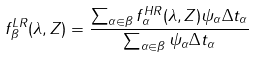Convert formula to latex. <formula><loc_0><loc_0><loc_500><loc_500>f ^ { L R } _ { \beta } ( \lambda , Z ) = \frac { \sum _ { \alpha \in \beta } f ^ { H R } _ { \alpha } ( \lambda , Z ) \psi _ { \alpha } \Delta t _ { \alpha } } { \sum _ { \alpha \in \beta } \psi _ { \alpha } \Delta t _ { \alpha } }</formula> 